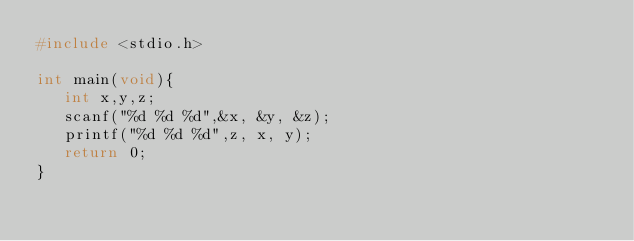<code> <loc_0><loc_0><loc_500><loc_500><_C++_>#include <stdio.h>

int main(void){
   int x,y,z;
   scanf("%d %d %d",&x, &y, &z);
   printf("%d %d %d",z, x, y);
   return 0;
}</code> 